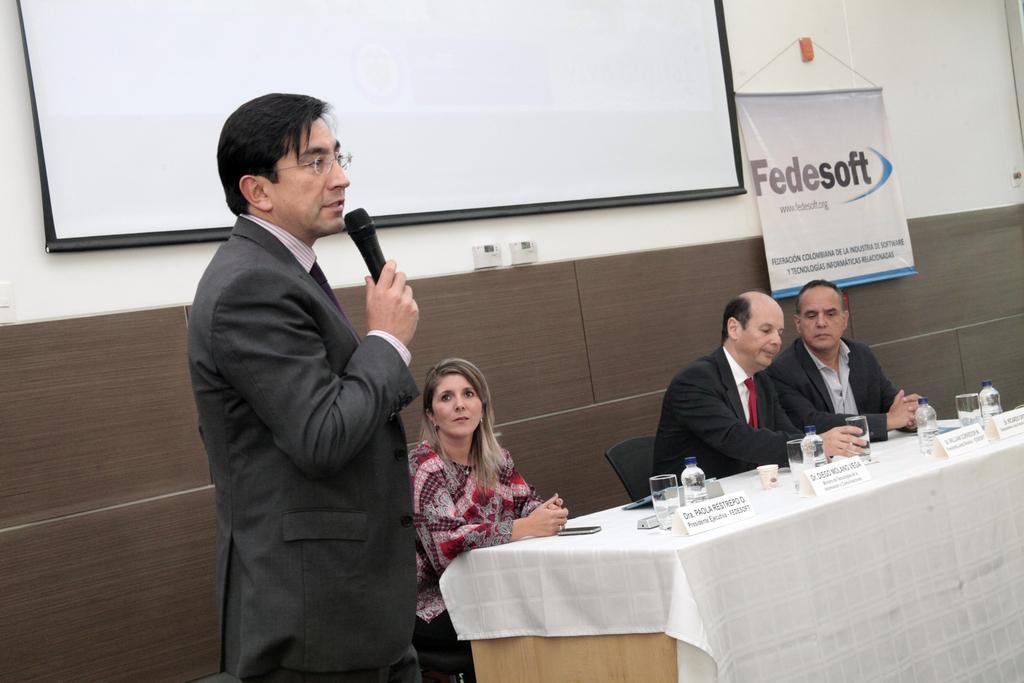Can you describe this image briefly? In this image on the left there is a man he wears suit, shirt he is holding a mic. On the right there are three people sitting on the chairs in front of them there is a table on that there are bottles and glasses. In the background there is white screen, poster and wall. 